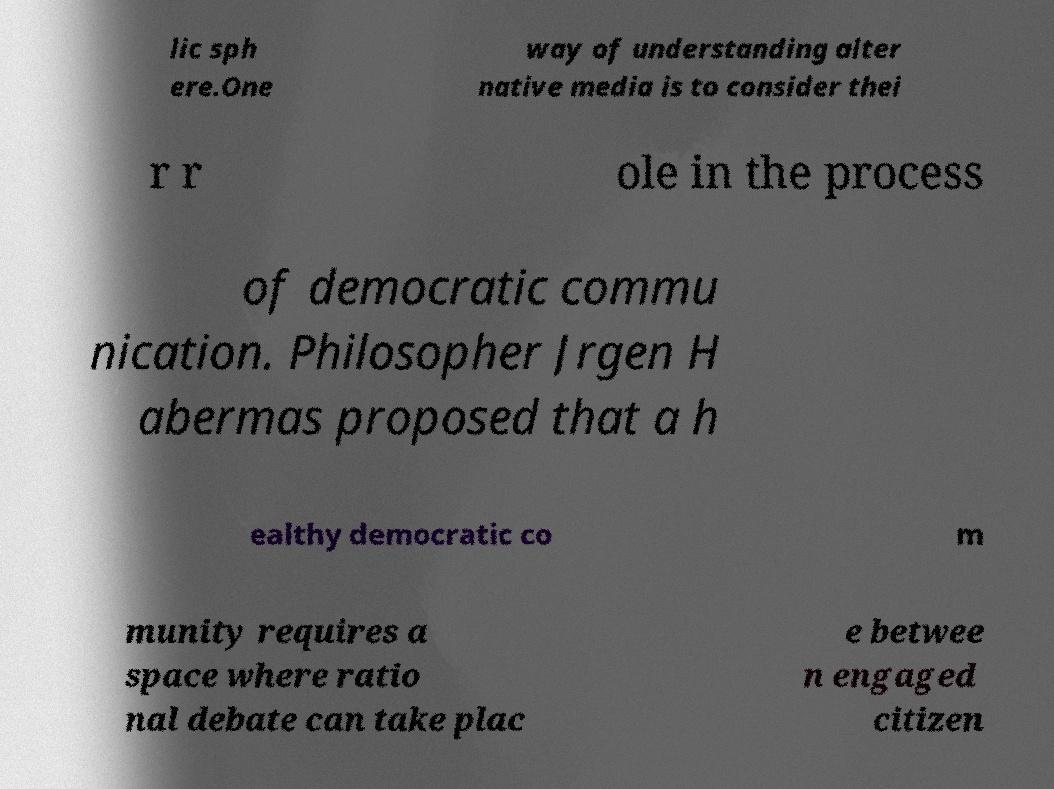What messages or text are displayed in this image? I need them in a readable, typed format. lic sph ere.One way of understanding alter native media is to consider thei r r ole in the process of democratic commu nication. Philosopher Jrgen H abermas proposed that a h ealthy democratic co m munity requires a space where ratio nal debate can take plac e betwee n engaged citizen 